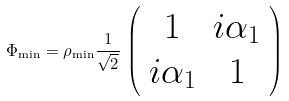<formula> <loc_0><loc_0><loc_500><loc_500>\Phi _ { \min } = \rho _ { \min } \frac { 1 } { \sqrt { 2 } } \, \left ( \begin{array} { c c } 1 & i \alpha _ { 1 } \\ i \alpha _ { 1 } & 1 \end{array} \right )</formula> 